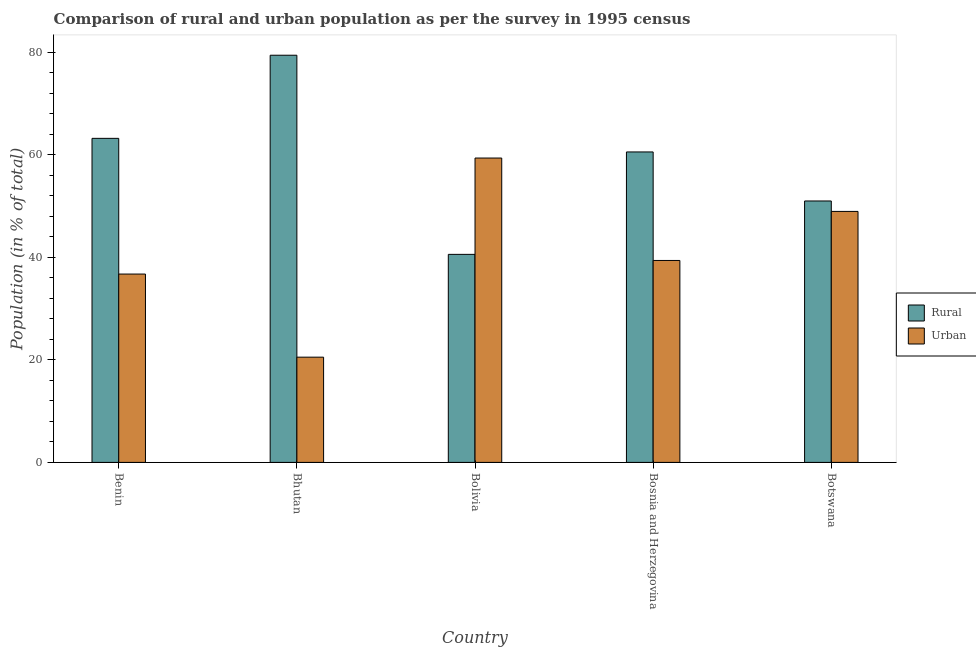How many different coloured bars are there?
Offer a terse response. 2. Are the number of bars per tick equal to the number of legend labels?
Make the answer very short. Yes. Are the number of bars on each tick of the X-axis equal?
Give a very brief answer. Yes. How many bars are there on the 1st tick from the right?
Provide a short and direct response. 2. What is the label of the 4th group of bars from the left?
Ensure brevity in your answer.  Bosnia and Herzegovina. What is the rural population in Bhutan?
Offer a terse response. 79.46. Across all countries, what is the maximum rural population?
Make the answer very short. 79.46. Across all countries, what is the minimum urban population?
Make the answer very short. 20.54. In which country was the urban population maximum?
Give a very brief answer. Bolivia. What is the total rural population in the graph?
Your answer should be compact. 294.91. What is the difference between the urban population in Benin and that in Botswana?
Keep it short and to the point. -12.22. What is the difference between the urban population in Benin and the rural population in Bhutan?
Keep it short and to the point. -42.71. What is the average rural population per country?
Offer a very short reply. 58.98. What is the difference between the rural population and urban population in Benin?
Give a very brief answer. 26.48. What is the ratio of the urban population in Benin to that in Bolivia?
Your answer should be compact. 0.62. What is the difference between the highest and the second highest rural population?
Your response must be concise. 16.22. What is the difference between the highest and the lowest rural population?
Ensure brevity in your answer.  38.86. In how many countries, is the urban population greater than the average urban population taken over all countries?
Make the answer very short. 2. Is the sum of the urban population in Bolivia and Bosnia and Herzegovina greater than the maximum rural population across all countries?
Ensure brevity in your answer.  Yes. What does the 1st bar from the left in Bolivia represents?
Your answer should be compact. Rural. What does the 1st bar from the right in Bhutan represents?
Offer a very short reply. Urban. How many bars are there?
Offer a terse response. 10. How many countries are there in the graph?
Your answer should be compact. 5. Are the values on the major ticks of Y-axis written in scientific E-notation?
Your response must be concise. No. Does the graph contain any zero values?
Offer a terse response. No. Does the graph contain grids?
Provide a short and direct response. No. Where does the legend appear in the graph?
Your answer should be compact. Center right. How many legend labels are there?
Offer a terse response. 2. What is the title of the graph?
Your answer should be very brief. Comparison of rural and urban population as per the survey in 1995 census. Does "Goods and services" appear as one of the legend labels in the graph?
Your answer should be very brief. No. What is the label or title of the X-axis?
Provide a short and direct response. Country. What is the label or title of the Y-axis?
Ensure brevity in your answer.  Population (in % of total). What is the Population (in % of total) of Rural in Benin?
Provide a short and direct response. 63.24. What is the Population (in % of total) of Urban in Benin?
Your answer should be compact. 36.76. What is the Population (in % of total) in Rural in Bhutan?
Make the answer very short. 79.46. What is the Population (in % of total) of Urban in Bhutan?
Offer a very short reply. 20.54. What is the Population (in % of total) of Rural in Bolivia?
Offer a very short reply. 40.6. What is the Population (in % of total) of Urban in Bolivia?
Give a very brief answer. 59.4. What is the Population (in % of total) in Rural in Bosnia and Herzegovina?
Provide a succinct answer. 60.59. What is the Population (in % of total) of Urban in Bosnia and Herzegovina?
Your response must be concise. 39.41. What is the Population (in % of total) in Rural in Botswana?
Provide a short and direct response. 51.02. What is the Population (in % of total) in Urban in Botswana?
Offer a very short reply. 48.98. Across all countries, what is the maximum Population (in % of total) of Rural?
Provide a short and direct response. 79.46. Across all countries, what is the maximum Population (in % of total) of Urban?
Keep it short and to the point. 59.4. Across all countries, what is the minimum Population (in % of total) of Rural?
Ensure brevity in your answer.  40.6. Across all countries, what is the minimum Population (in % of total) in Urban?
Offer a terse response. 20.54. What is the total Population (in % of total) in Rural in the graph?
Your answer should be very brief. 294.91. What is the total Population (in % of total) of Urban in the graph?
Give a very brief answer. 205.09. What is the difference between the Population (in % of total) in Rural in Benin and that in Bhutan?
Provide a short and direct response. -16.22. What is the difference between the Population (in % of total) in Urban in Benin and that in Bhutan?
Give a very brief answer. 16.22. What is the difference between the Population (in % of total) of Rural in Benin and that in Bolivia?
Make the answer very short. 22.64. What is the difference between the Population (in % of total) in Urban in Benin and that in Bolivia?
Your answer should be compact. -22.64. What is the difference between the Population (in % of total) of Rural in Benin and that in Bosnia and Herzegovina?
Ensure brevity in your answer.  2.65. What is the difference between the Population (in % of total) in Urban in Benin and that in Bosnia and Herzegovina?
Your answer should be very brief. -2.65. What is the difference between the Population (in % of total) in Rural in Benin and that in Botswana?
Offer a very short reply. 12.22. What is the difference between the Population (in % of total) of Urban in Benin and that in Botswana?
Keep it short and to the point. -12.22. What is the difference between the Population (in % of total) of Rural in Bhutan and that in Bolivia?
Your answer should be very brief. 38.86. What is the difference between the Population (in % of total) of Urban in Bhutan and that in Bolivia?
Ensure brevity in your answer.  -38.86. What is the difference between the Population (in % of total) of Rural in Bhutan and that in Bosnia and Herzegovina?
Provide a short and direct response. 18.87. What is the difference between the Population (in % of total) in Urban in Bhutan and that in Bosnia and Herzegovina?
Keep it short and to the point. -18.87. What is the difference between the Population (in % of total) of Rural in Bhutan and that in Botswana?
Ensure brevity in your answer.  28.44. What is the difference between the Population (in % of total) of Urban in Bhutan and that in Botswana?
Provide a succinct answer. -28.44. What is the difference between the Population (in % of total) of Rural in Bolivia and that in Bosnia and Herzegovina?
Provide a short and direct response. -19.99. What is the difference between the Population (in % of total) in Urban in Bolivia and that in Bosnia and Herzegovina?
Offer a very short reply. 19.99. What is the difference between the Population (in % of total) in Rural in Bolivia and that in Botswana?
Offer a very short reply. -10.42. What is the difference between the Population (in % of total) in Urban in Bolivia and that in Botswana?
Your response must be concise. 10.42. What is the difference between the Population (in % of total) in Rural in Bosnia and Herzegovina and that in Botswana?
Keep it short and to the point. 9.57. What is the difference between the Population (in % of total) of Urban in Bosnia and Herzegovina and that in Botswana?
Give a very brief answer. -9.57. What is the difference between the Population (in % of total) of Rural in Benin and the Population (in % of total) of Urban in Bhutan?
Your response must be concise. 42.7. What is the difference between the Population (in % of total) of Rural in Benin and the Population (in % of total) of Urban in Bolivia?
Ensure brevity in your answer.  3.84. What is the difference between the Population (in % of total) of Rural in Benin and the Population (in % of total) of Urban in Bosnia and Herzegovina?
Your response must be concise. 23.83. What is the difference between the Population (in % of total) of Rural in Benin and the Population (in % of total) of Urban in Botswana?
Your response must be concise. 14.26. What is the difference between the Population (in % of total) of Rural in Bhutan and the Population (in % of total) of Urban in Bolivia?
Offer a terse response. 20.06. What is the difference between the Population (in % of total) of Rural in Bhutan and the Population (in % of total) of Urban in Bosnia and Herzegovina?
Ensure brevity in your answer.  40.05. What is the difference between the Population (in % of total) in Rural in Bhutan and the Population (in % of total) in Urban in Botswana?
Provide a succinct answer. 30.48. What is the difference between the Population (in % of total) of Rural in Bolivia and the Population (in % of total) of Urban in Bosnia and Herzegovina?
Give a very brief answer. 1.19. What is the difference between the Population (in % of total) in Rural in Bolivia and the Population (in % of total) in Urban in Botswana?
Give a very brief answer. -8.38. What is the difference between the Population (in % of total) of Rural in Bosnia and Herzegovina and the Population (in % of total) of Urban in Botswana?
Provide a short and direct response. 11.61. What is the average Population (in % of total) in Rural per country?
Keep it short and to the point. 58.98. What is the average Population (in % of total) in Urban per country?
Your answer should be very brief. 41.02. What is the difference between the Population (in % of total) in Rural and Population (in % of total) in Urban in Benin?
Make the answer very short. 26.48. What is the difference between the Population (in % of total) in Rural and Population (in % of total) in Urban in Bhutan?
Ensure brevity in your answer.  58.93. What is the difference between the Population (in % of total) in Rural and Population (in % of total) in Urban in Bolivia?
Give a very brief answer. -18.8. What is the difference between the Population (in % of total) of Rural and Population (in % of total) of Urban in Bosnia and Herzegovina?
Offer a very short reply. 21.18. What is the difference between the Population (in % of total) of Rural and Population (in % of total) of Urban in Botswana?
Your answer should be compact. 2.04. What is the ratio of the Population (in % of total) in Rural in Benin to that in Bhutan?
Offer a very short reply. 0.8. What is the ratio of the Population (in % of total) in Urban in Benin to that in Bhutan?
Your answer should be very brief. 1.79. What is the ratio of the Population (in % of total) of Rural in Benin to that in Bolivia?
Give a very brief answer. 1.56. What is the ratio of the Population (in % of total) of Urban in Benin to that in Bolivia?
Provide a short and direct response. 0.62. What is the ratio of the Population (in % of total) in Rural in Benin to that in Bosnia and Herzegovina?
Your response must be concise. 1.04. What is the ratio of the Population (in % of total) of Urban in Benin to that in Bosnia and Herzegovina?
Provide a succinct answer. 0.93. What is the ratio of the Population (in % of total) of Rural in Benin to that in Botswana?
Your answer should be compact. 1.24. What is the ratio of the Population (in % of total) in Urban in Benin to that in Botswana?
Offer a very short reply. 0.75. What is the ratio of the Population (in % of total) of Rural in Bhutan to that in Bolivia?
Give a very brief answer. 1.96. What is the ratio of the Population (in % of total) of Urban in Bhutan to that in Bolivia?
Provide a succinct answer. 0.35. What is the ratio of the Population (in % of total) in Rural in Bhutan to that in Bosnia and Herzegovina?
Make the answer very short. 1.31. What is the ratio of the Population (in % of total) of Urban in Bhutan to that in Bosnia and Herzegovina?
Keep it short and to the point. 0.52. What is the ratio of the Population (in % of total) in Rural in Bhutan to that in Botswana?
Offer a very short reply. 1.56. What is the ratio of the Population (in % of total) in Urban in Bhutan to that in Botswana?
Offer a very short reply. 0.42. What is the ratio of the Population (in % of total) of Rural in Bolivia to that in Bosnia and Herzegovina?
Offer a terse response. 0.67. What is the ratio of the Population (in % of total) of Urban in Bolivia to that in Bosnia and Herzegovina?
Your response must be concise. 1.51. What is the ratio of the Population (in % of total) of Rural in Bolivia to that in Botswana?
Your answer should be compact. 0.8. What is the ratio of the Population (in % of total) of Urban in Bolivia to that in Botswana?
Your response must be concise. 1.21. What is the ratio of the Population (in % of total) in Rural in Bosnia and Herzegovina to that in Botswana?
Your answer should be compact. 1.19. What is the ratio of the Population (in % of total) in Urban in Bosnia and Herzegovina to that in Botswana?
Ensure brevity in your answer.  0.8. What is the difference between the highest and the second highest Population (in % of total) in Rural?
Your answer should be very brief. 16.22. What is the difference between the highest and the second highest Population (in % of total) in Urban?
Offer a very short reply. 10.42. What is the difference between the highest and the lowest Population (in % of total) in Rural?
Make the answer very short. 38.86. What is the difference between the highest and the lowest Population (in % of total) in Urban?
Ensure brevity in your answer.  38.86. 